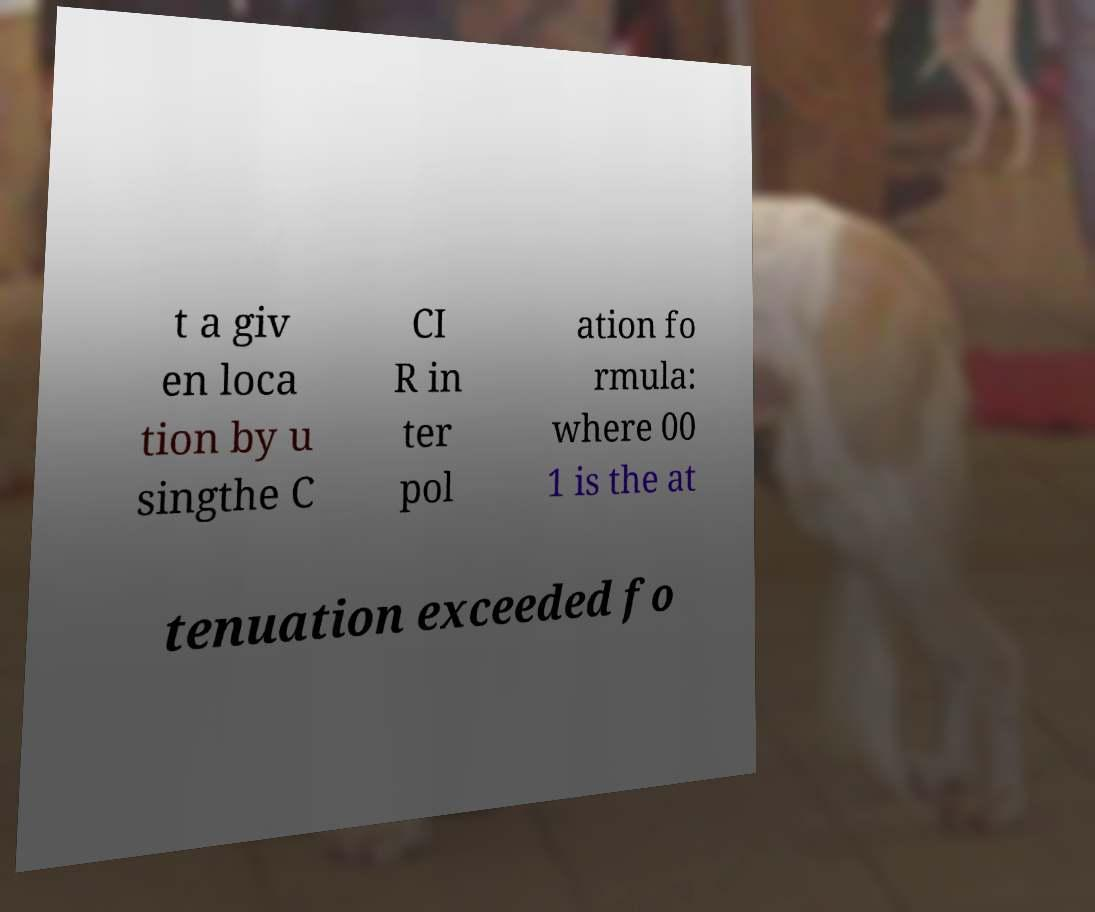Please identify and transcribe the text found in this image. t a giv en loca tion by u singthe C CI R in ter pol ation fo rmula: where 00 1 is the at tenuation exceeded fo 